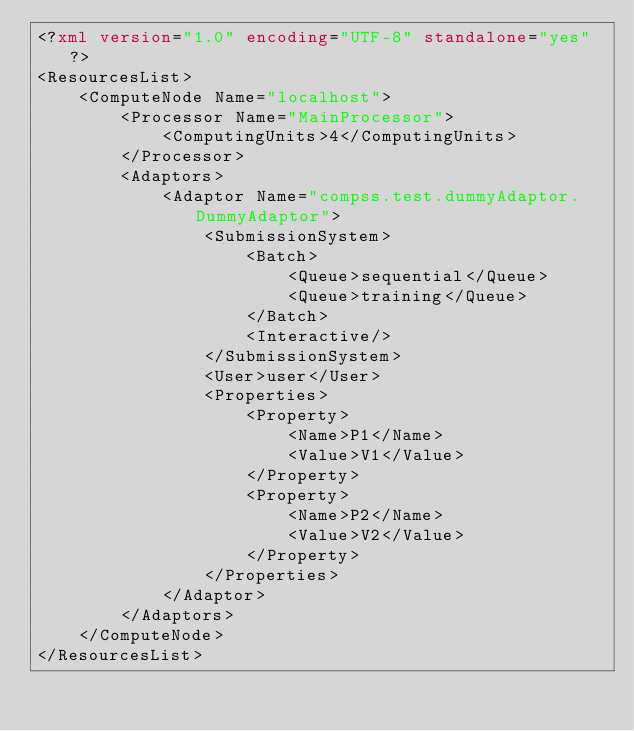<code> <loc_0><loc_0><loc_500><loc_500><_XML_><?xml version="1.0" encoding="UTF-8" standalone="yes"?>
<ResourcesList>
    <ComputeNode Name="localhost">
        <Processor Name="MainProcessor">
            <ComputingUnits>4</ComputingUnits>
        </Processor>
        <Adaptors>
            <Adaptor Name="compss.test.dummyAdaptor.DummyAdaptor">
                <SubmissionSystem>
                    <Batch>
                        <Queue>sequential</Queue>
                        <Queue>training</Queue>
                    </Batch>
                    <Interactive/>
                </SubmissionSystem>
                <User>user</User>
                <Properties>
                    <Property>
                        <Name>P1</Name>
                        <Value>V1</Value>
                    </Property>
                    <Property>
                        <Name>P2</Name>
                        <Value>V2</Value>
                    </Property>
                </Properties>
            </Adaptor>
        </Adaptors>
    </ComputeNode>
</ResourcesList></code> 